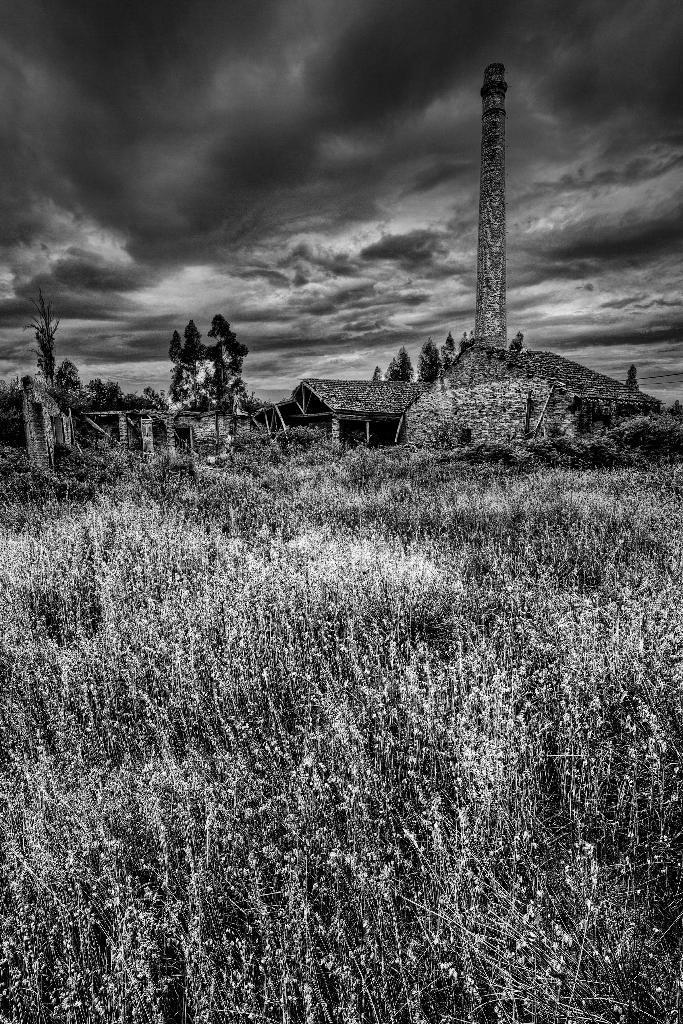Describe this image in one or two sentences. This is a black and white image. There are trees, houses, plants and a tower. In the background, there is the sky. 